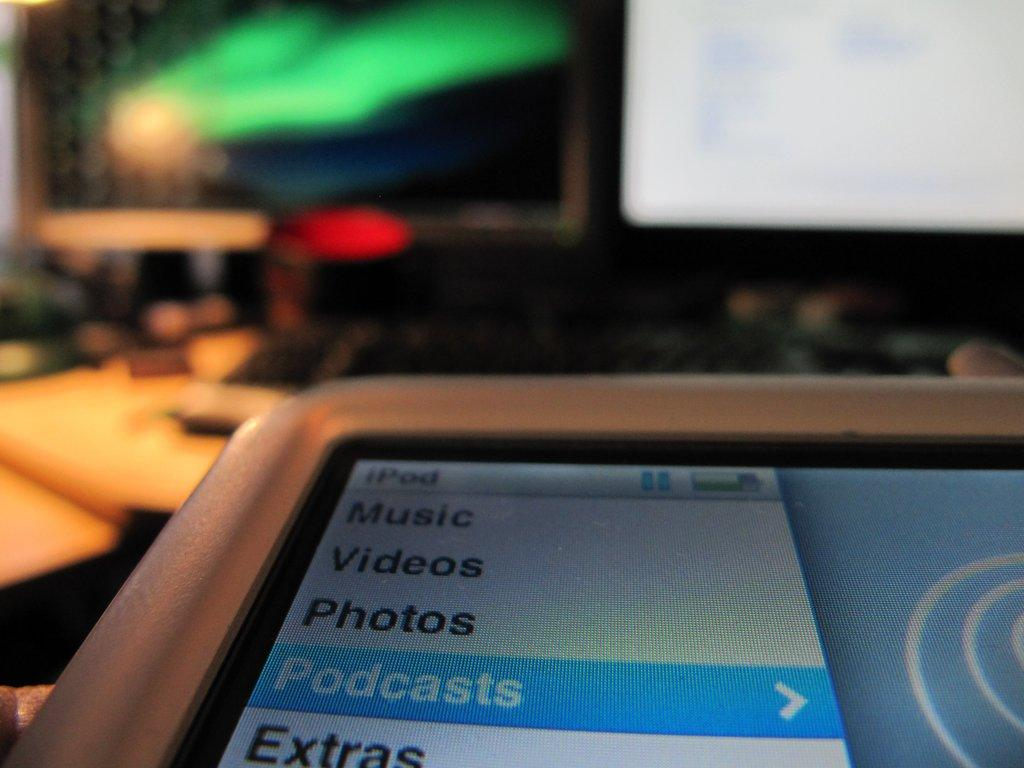<image>
Share a concise interpretation of the image provided. Podcasts is highlighted in blue on a screen. 